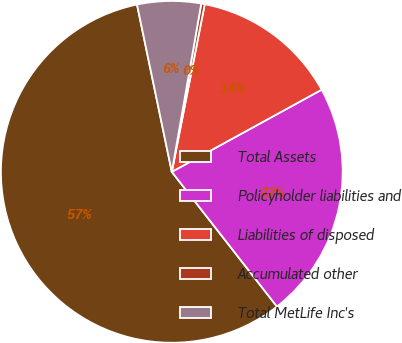Convert chart to OTSL. <chart><loc_0><loc_0><loc_500><loc_500><pie_chart><fcel>Total Assets<fcel>Policyholder liabilities and<fcel>Liabilities of disposed<fcel>Accumulated other<fcel>Total MetLife Inc's<nl><fcel>57.28%<fcel>22.43%<fcel>13.93%<fcel>0.33%<fcel>6.02%<nl></chart> 